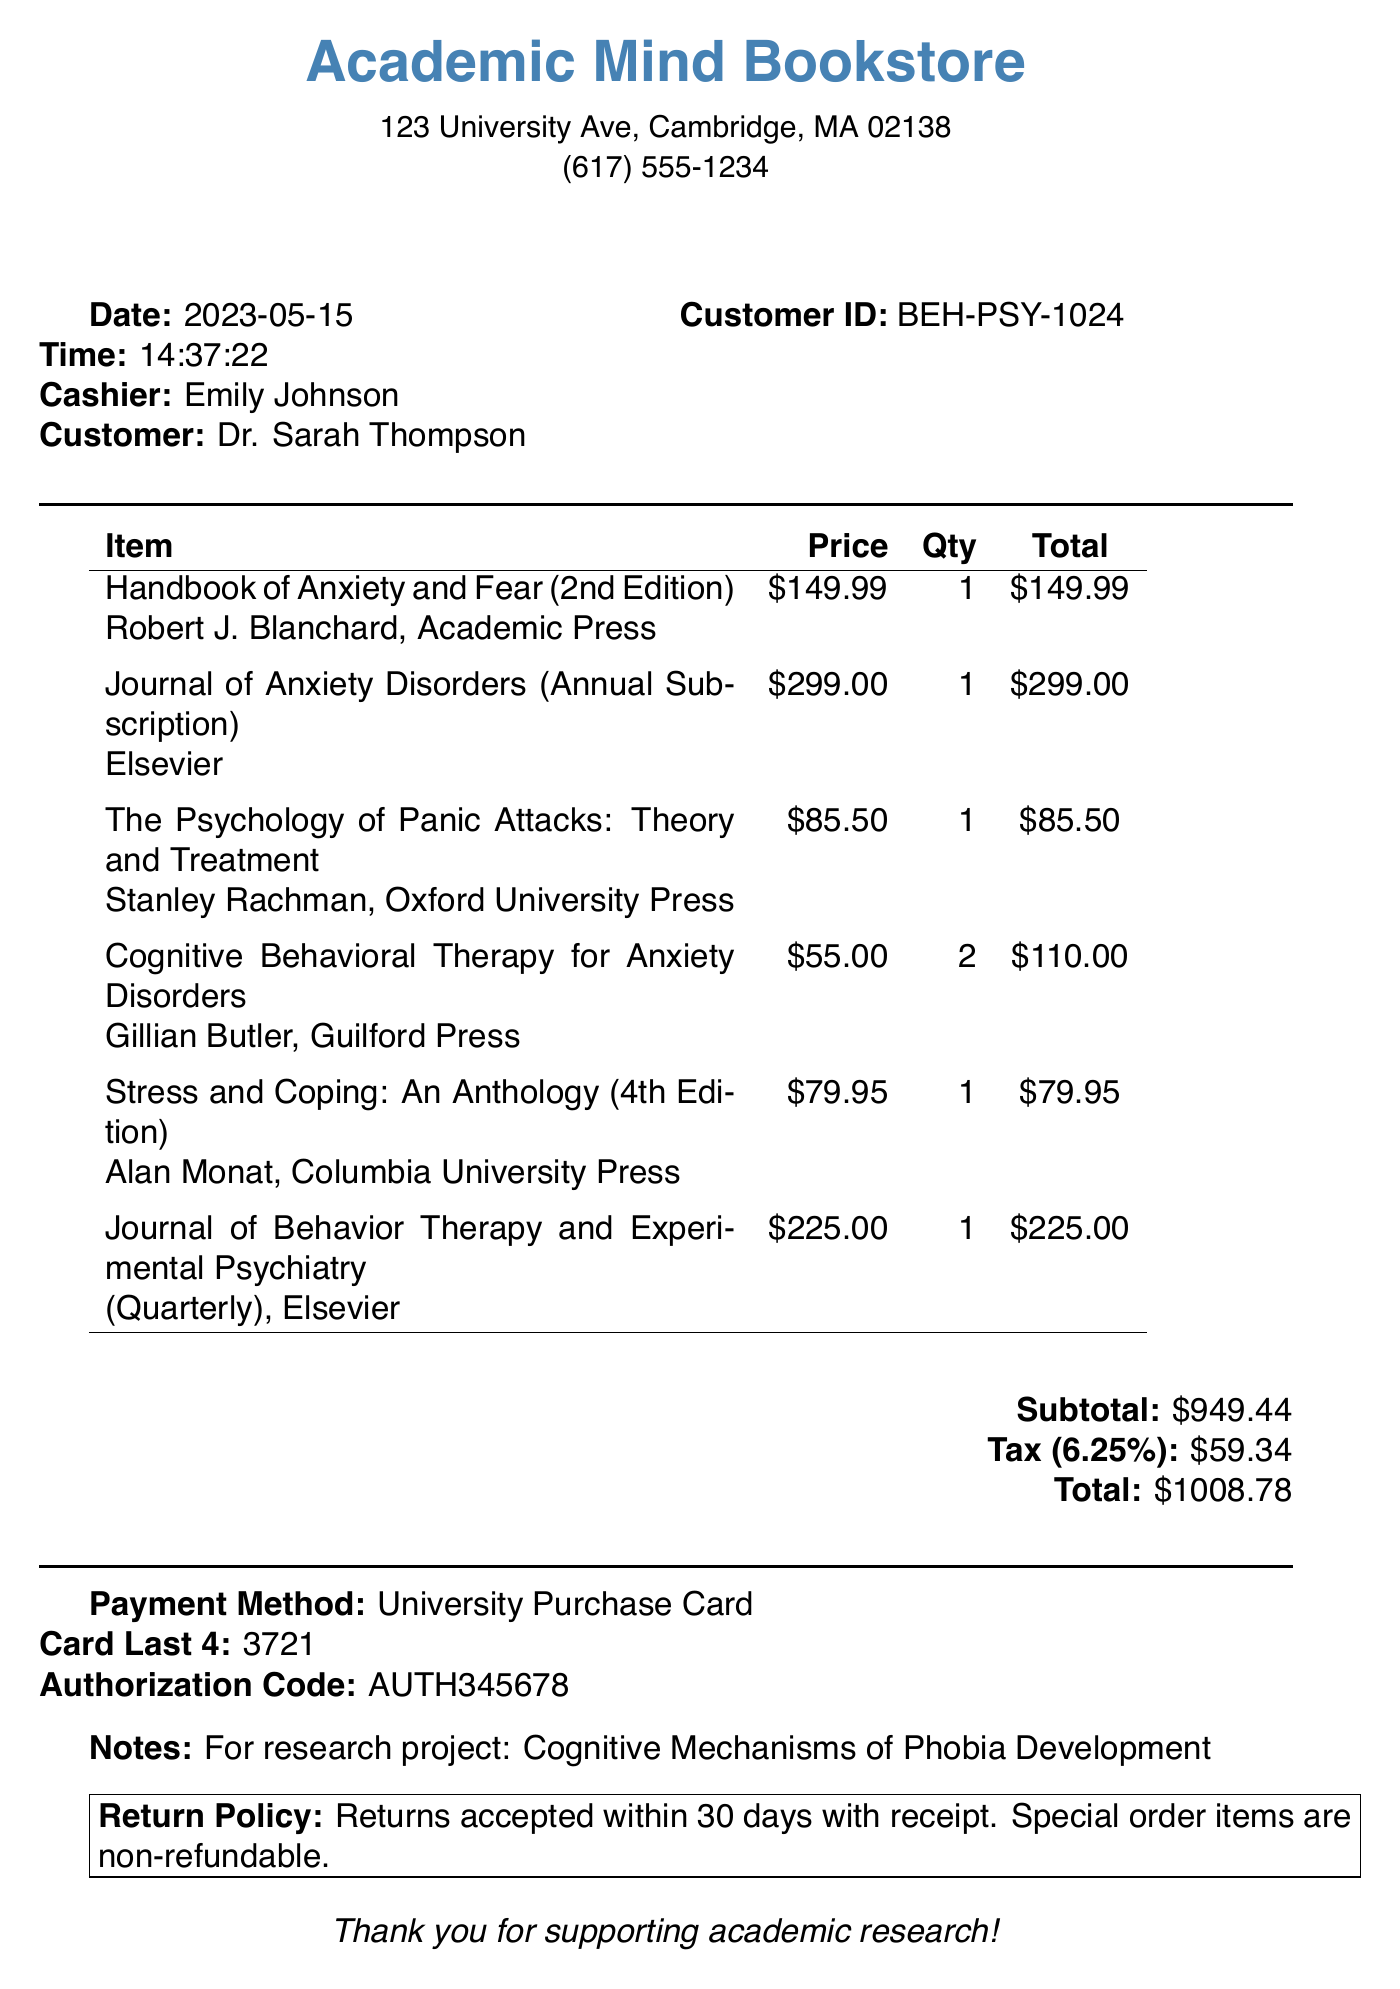What is the store name? The store name is clearly labeled at the top of the receipt.
Answer: Academic Mind Bookstore Who is the customer? The receipt states the customer's name in the designated area for customer information.
Answer: Dr. Sarah Thompson What is the subtotal amount? The subtotal is listed in the financial summary section of the receipt.
Answer: $949.44 What was purchased in quantity of 2? The receipt details the items and their quantities in the list of purchased items.
Answer: Cognitive Behavioral Therapy for Anxiety Disorders What is the date of purchase? The date is noted prominently on the receipt under the purchase information.
Answer: 2023-05-15 What is the tax rate applied to the purchase? The tax rate is specified in the tax calculation part of the receipt summary.
Answer: 6.25% What is the total amount after tax? The total is calculated by adding the subtotal and tax, presented at the end of the receipt.
Answer: $1008.78 Who was the cashier? The cashier's name is mentioned next to the date and time of the transaction.
Answer: Emily Johnson What is the return policy? The return policy is summarized in the boxed section at the bottom of the receipt.
Answer: Returns accepted within 30 days with receipt 